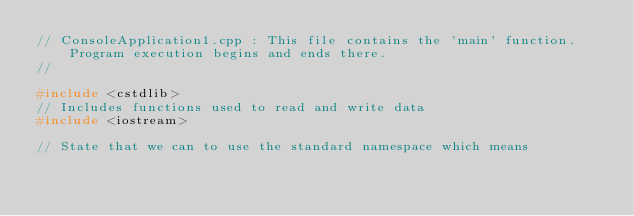<code> <loc_0><loc_0><loc_500><loc_500><_C++_>// ConsoleApplication1.cpp : This file contains the 'main' function. Program execution begins and ends there.
//

#include <cstdlib>
// Includes functions used to read and write data
#include <iostream>

// State that we can to use the standard namespace which means</code> 